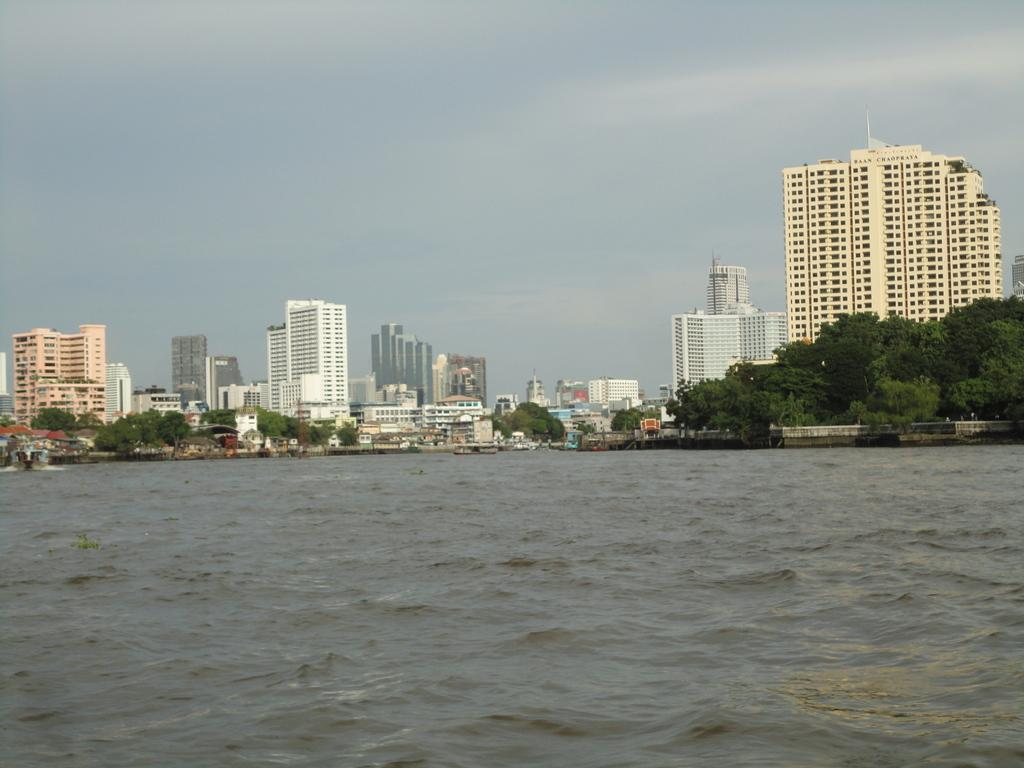What is the main subject in the center of the image? There is water in the center of the image. What can be seen in the background of the image? There are trees and buildings in the background of the image. How would you describe the sky in the image? The sky is cloudy in the image. What type of design can be seen on the dock in the image? There is no dock present in the image; it features water, trees, buildings, and a cloudy sky. 